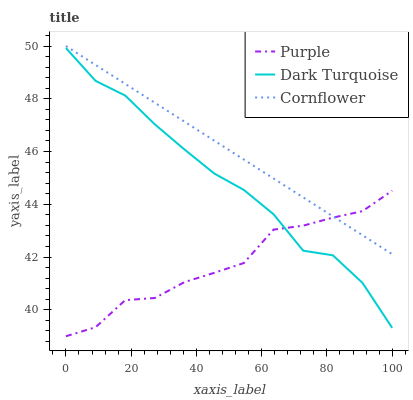Does Purple have the minimum area under the curve?
Answer yes or no. Yes. Does Cornflower have the maximum area under the curve?
Answer yes or no. Yes. Does Dark Turquoise have the minimum area under the curve?
Answer yes or no. No. Does Dark Turquoise have the maximum area under the curve?
Answer yes or no. No. Is Cornflower the smoothest?
Answer yes or no. Yes. Is Dark Turquoise the roughest?
Answer yes or no. Yes. Is Dark Turquoise the smoothest?
Answer yes or no. No. Is Cornflower the roughest?
Answer yes or no. No. Does Purple have the lowest value?
Answer yes or no. Yes. Does Dark Turquoise have the lowest value?
Answer yes or no. No. Does Cornflower have the highest value?
Answer yes or no. Yes. Does Dark Turquoise have the highest value?
Answer yes or no. No. Is Dark Turquoise less than Cornflower?
Answer yes or no. Yes. Is Cornflower greater than Dark Turquoise?
Answer yes or no. Yes. Does Dark Turquoise intersect Purple?
Answer yes or no. Yes. Is Dark Turquoise less than Purple?
Answer yes or no. No. Is Dark Turquoise greater than Purple?
Answer yes or no. No. Does Dark Turquoise intersect Cornflower?
Answer yes or no. No. 